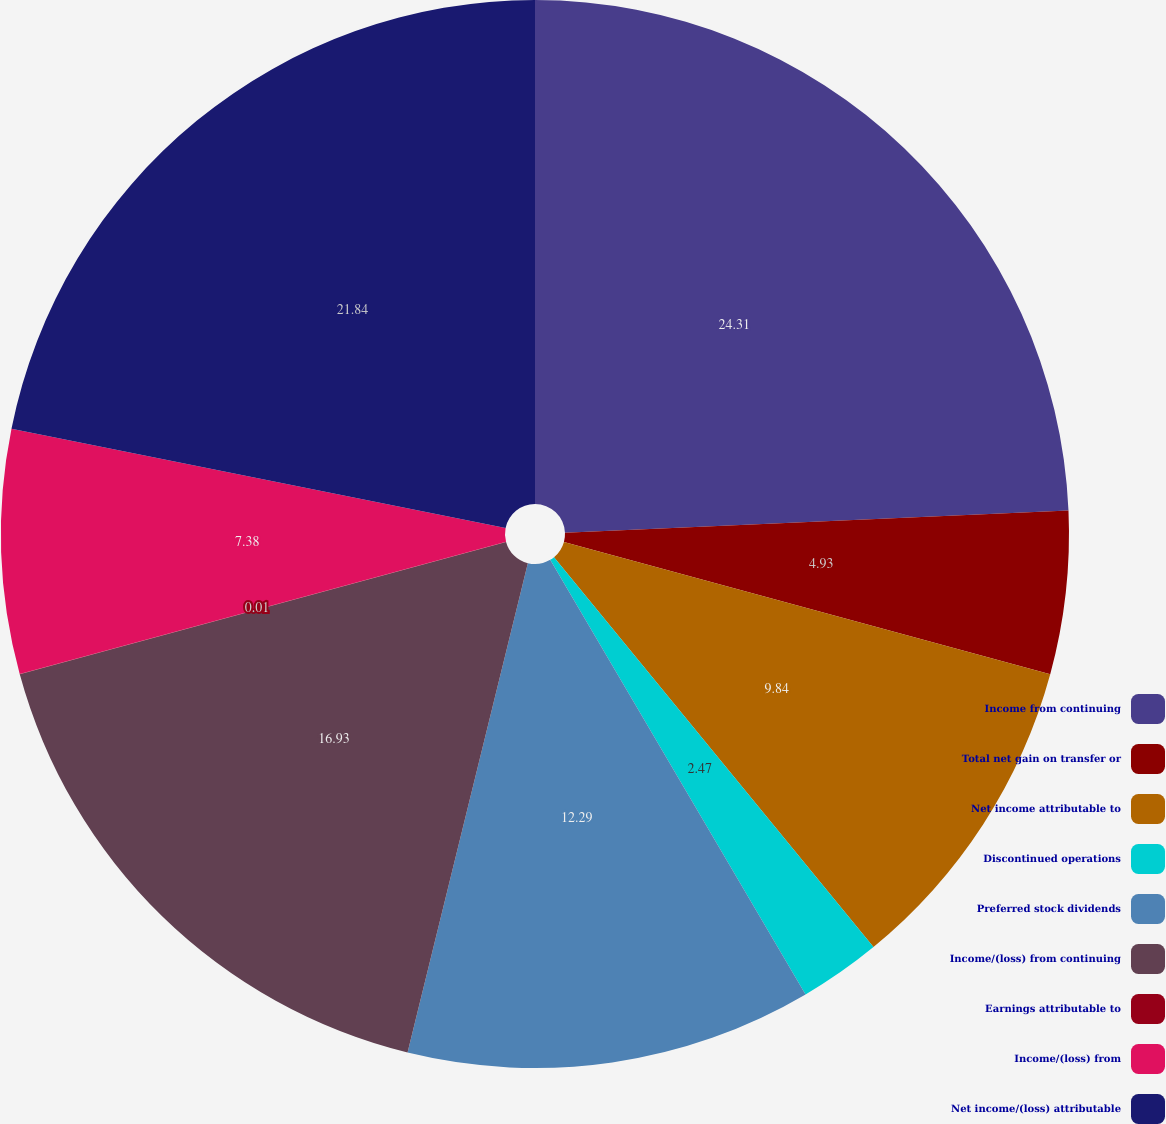Convert chart. <chart><loc_0><loc_0><loc_500><loc_500><pie_chart><fcel>Income from continuing<fcel>Total net gain on transfer or<fcel>Net income attributable to<fcel>Discontinued operations<fcel>Preferred stock dividends<fcel>Income/(loss) from continuing<fcel>Earnings attributable to<fcel>Income/(loss) from<fcel>Net income/(loss) attributable<nl><fcel>24.3%<fcel>4.93%<fcel>9.84%<fcel>2.47%<fcel>12.29%<fcel>16.93%<fcel>0.01%<fcel>7.38%<fcel>21.84%<nl></chart> 